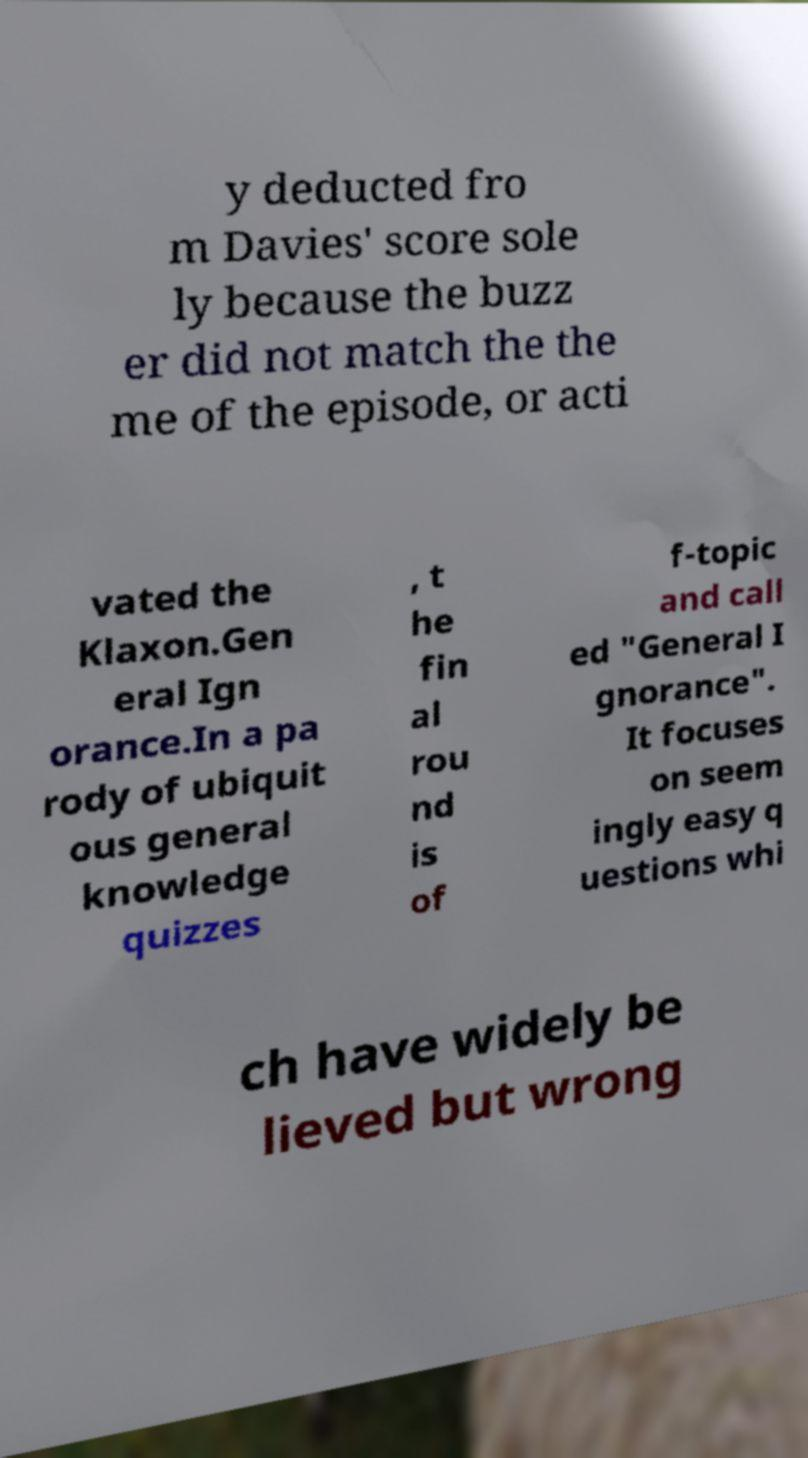I need the written content from this picture converted into text. Can you do that? y deducted fro m Davies' score sole ly because the buzz er did not match the the me of the episode, or acti vated the Klaxon.Gen eral Ign orance.In a pa rody of ubiquit ous general knowledge quizzes , t he fin al rou nd is of f-topic and call ed "General I gnorance". It focuses on seem ingly easy q uestions whi ch have widely be lieved but wrong 